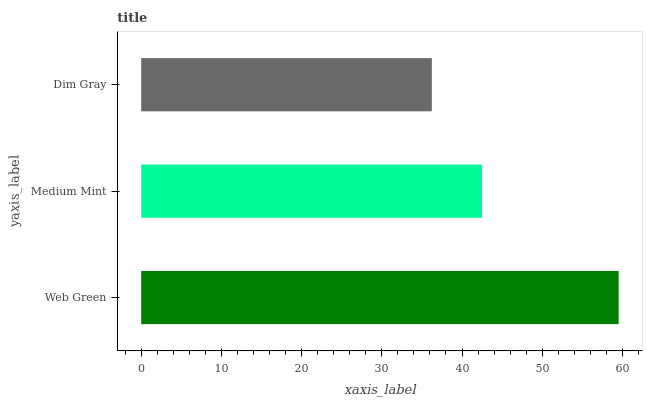Is Dim Gray the minimum?
Answer yes or no. Yes. Is Web Green the maximum?
Answer yes or no. Yes. Is Medium Mint the minimum?
Answer yes or no. No. Is Medium Mint the maximum?
Answer yes or no. No. Is Web Green greater than Medium Mint?
Answer yes or no. Yes. Is Medium Mint less than Web Green?
Answer yes or no. Yes. Is Medium Mint greater than Web Green?
Answer yes or no. No. Is Web Green less than Medium Mint?
Answer yes or no. No. Is Medium Mint the high median?
Answer yes or no. Yes. Is Medium Mint the low median?
Answer yes or no. Yes. Is Dim Gray the high median?
Answer yes or no. No. Is Web Green the low median?
Answer yes or no. No. 